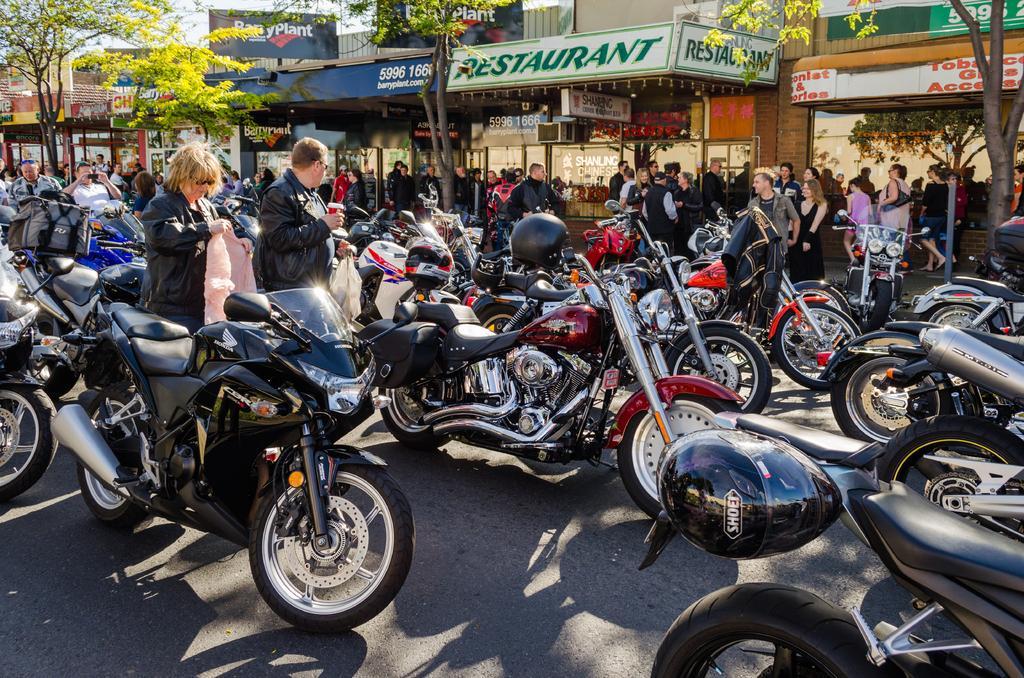Could you give a brief overview of what you see in this image? In this image I can see few bikes,helmets,jackets. I can see few people and holding something. I can see few stores and trees. 